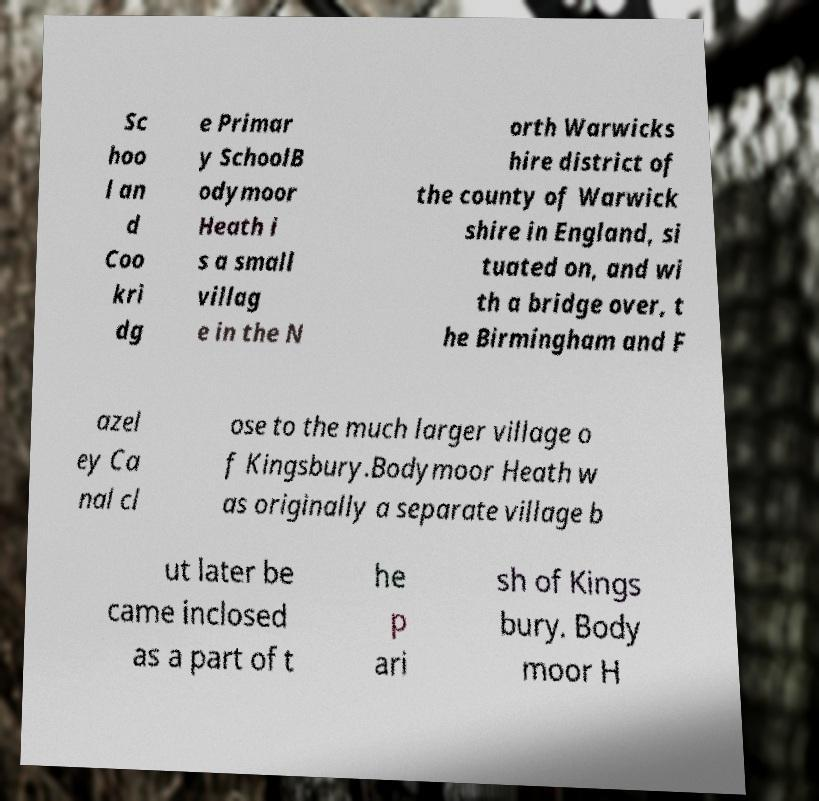Can you read and provide the text displayed in the image?This photo seems to have some interesting text. Can you extract and type it out for me? Sc hoo l an d Coo kri dg e Primar y SchoolB odymoor Heath i s a small villag e in the N orth Warwicks hire district of the county of Warwick shire in England, si tuated on, and wi th a bridge over, t he Birmingham and F azel ey Ca nal cl ose to the much larger village o f Kingsbury.Bodymoor Heath w as originally a separate village b ut later be came inclosed as a part of t he p ari sh of Kings bury. Body moor H 